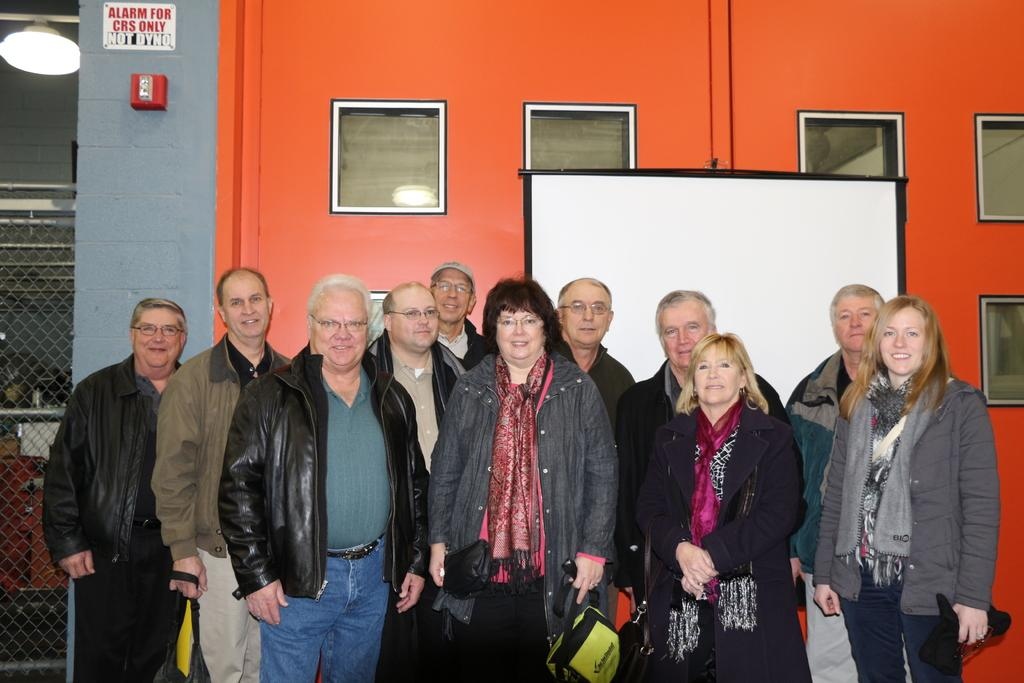Who is the main subject in the image? There is a woman standing in the middle of the image. What is the woman wearing? The woman is wearing a coat. Are there any other people in the image? Yes, there are other persons standing in the image. What can be seen in the background of the image? There is an orange color wall in the background of the image. How many cherries can be seen on the hill in the image? There are no cherries or hills present in the image. 